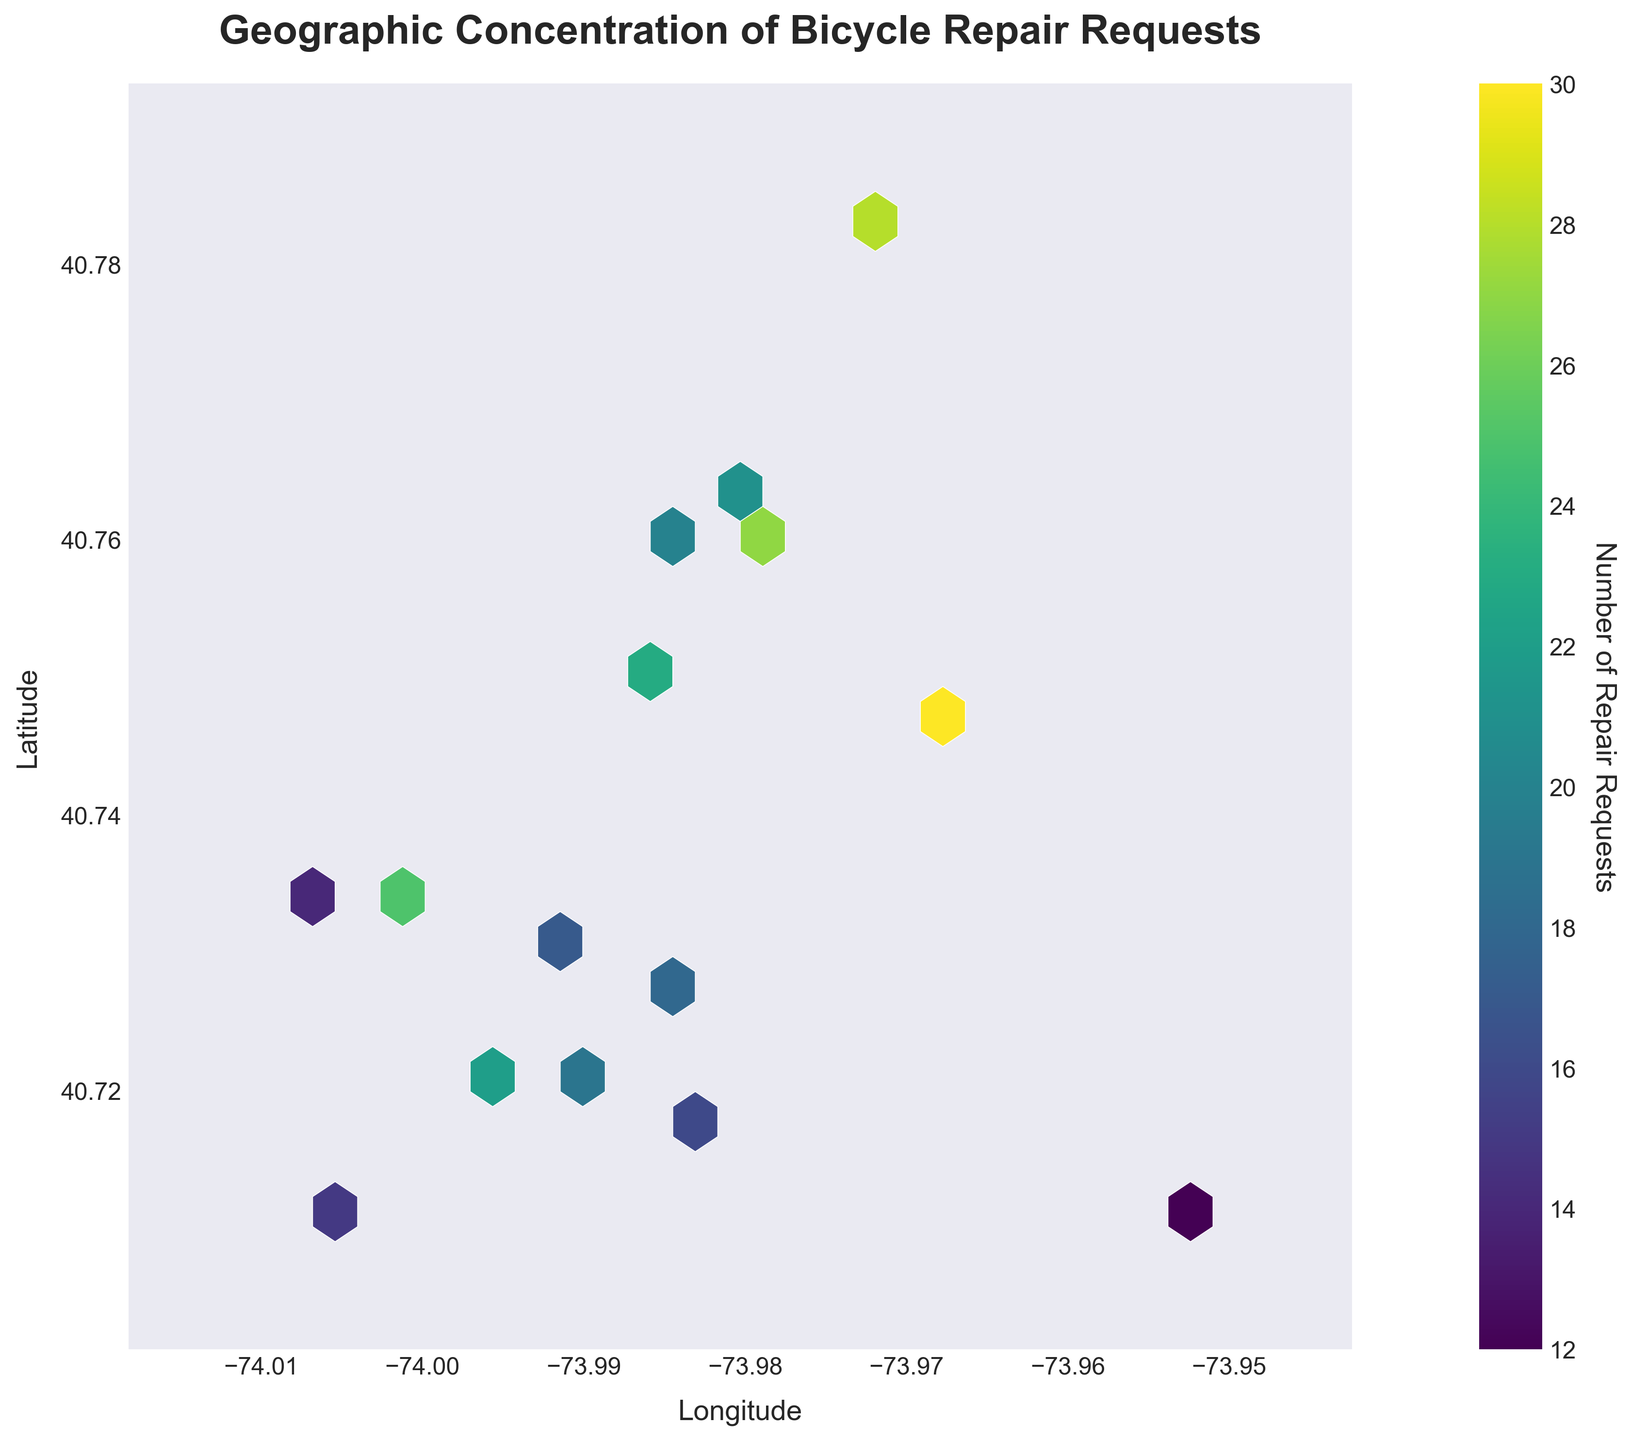What is the title of the plot? The title of the plot is displayed prominently at the top of the figure and reads "Geographic Concentration of Bicycle Repair Requests".
Answer: Geographic Concentration of Bicycle Repair Requests What does the color indicate in the hexbin plot? The color in the hexbin plot indicates the number of repair requests, as described in the hexbin plot's colorbar on the right side of the figure.
Answer: Number of repair requests What are the x and y axes labeled? The x-axis is labeled 'Longitude' and the y-axis is labeled 'Latitude', as seen on the respective axes of the figure.
Answer: Longitude, Latitude Which geographic area seems to have the highest concentration of repair requests? The highest concentration of repair requests is indicated by the darkest color in the plot, which appears around the coordinates near (40.7489, -73.9680).
Answer: Around (40.7489, -73.9680) How does the number of repair requests vary geographically? The number of repair requests can be observed to vary geographically, with higher concentrations (darker colors) in some areas and lower concentrations (lighter colors) in others. The city center seems to have more requests compared to the outskirts.
Answer: Varies by region, higher in city center Are there areas with no repair requests? Areas with no repair requests would be represented by blank spots (no hexagons), especially on the outskirts of the geographic range plotted, as there is no color data there.
Answer: Yes, on outskirts What is the least dense geographic area for repair requests? The least dense geographic area for repair requests is indicated by the lightest color on the plot, which appears around the fringe coordinates such as near (40.7112, -73.9524).
Answer: Around (40.7112, -73.9524) How does the density of repair requests change as you move from west to east? As you move from west to east, the density of repair requests appears to decrease initially, then increases around the central longitude values, and may decrease again towards the far east.
Answer: Decreases, then increases, then decreases Comparing the northern and southern parts of the plot, which has more repair requests? By comparing the color densities in the plot, the northern part appears to have more repair requests than the southern part, as evidenced by the darker hexagons predominantly in the northern region around coordinates like (40.7831, -73.9712).
Answer: Northern part 